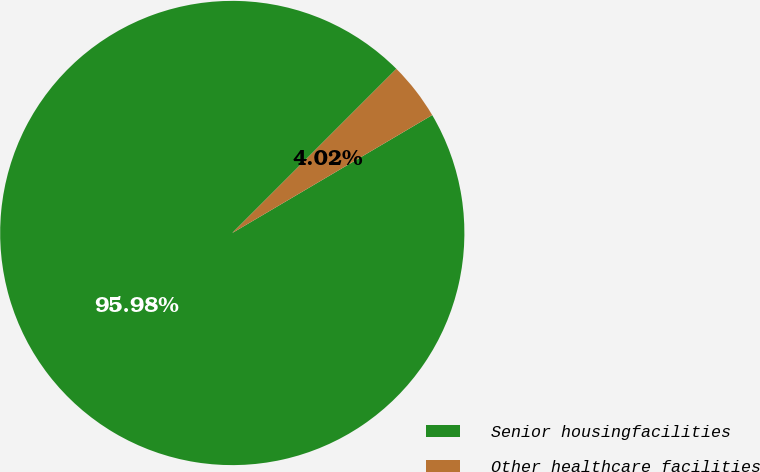Convert chart. <chart><loc_0><loc_0><loc_500><loc_500><pie_chart><fcel>Senior housingfacilities<fcel>Other healthcare facilities<nl><fcel>95.98%<fcel>4.02%<nl></chart> 